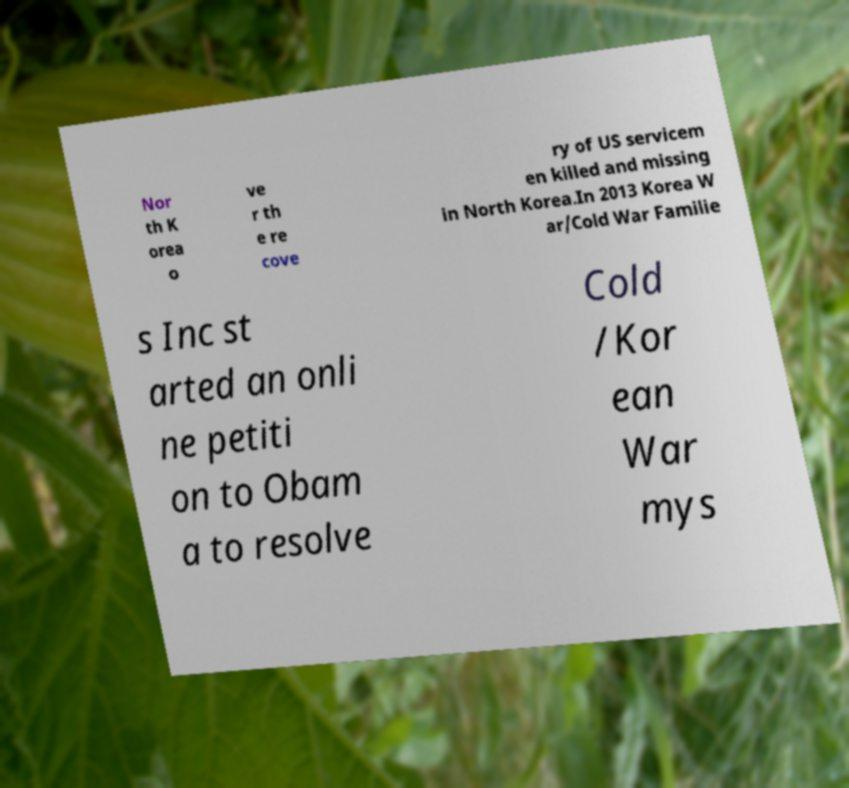Could you extract and type out the text from this image? Nor th K orea o ve r th e re cove ry of US servicem en killed and missing in North Korea.In 2013 Korea W ar/Cold War Familie s Inc st arted an onli ne petiti on to Obam a to resolve Cold /Kor ean War mys 